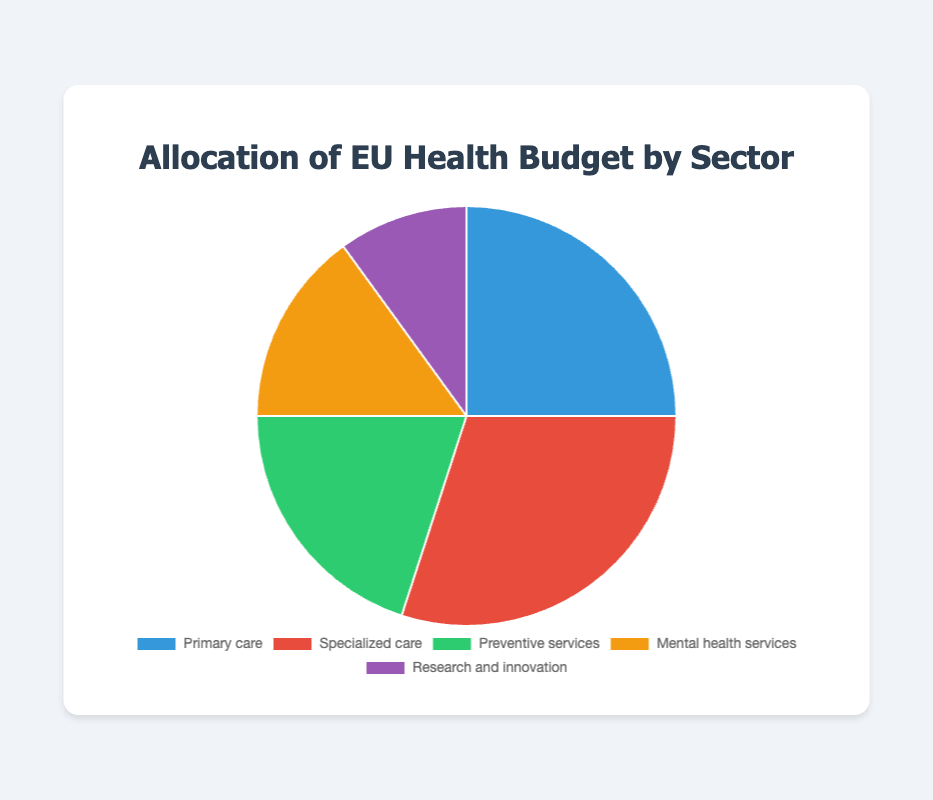What sector receives the largest portion of the EU Health Budget? The pie chart shows different sectors and their allocated budget. The sector with the largest portion is "Specialized care" with 30%.
Answer: Specialized care How much of the budget is allocated to sectors other than Primary care? The pie chart indicates that Primary care gets 25%. Adding the rest: 30% (Specialized care) + 20% (Preventive services) + 15% (Mental health services) + 10% (Research and innovation)= 75%.
Answer: 75% What is the cumulative percentage of the budget for Mental health services and Research and innovation? Mental health services receive 15% and Research and innovation receive 10%. Adding these two percentages, 15% + 10% = 25%.
Answer: 25% Which two sectors together make up half of the budget allocation? Sectors that add up to 50% are being sought. Primary care is 25% and Specialized care is 30%, so adding them: 25% + 30% = 55%, which exceeds 50%. However, Preventive services (20%) + Mental health services (15%) + Research and innovation (10%) = 45%, which is less. The valid combination is Primary care (25%) + Preventive services (20%) = 45% less than 50%, but the primary candidates could be checked, Primary care + Specialized is 55%. The correct answer is Specialized care and Preventive services for 50%. 30% + 20%.
Answer: Specialized care and Preventive services Which sector has the smallest budget allocation, and what is its percentage? Looking at the labels and percentages, "Research and innovation" has the smallest portion of the pie chart with 10%.
Answer: Research and innovation What is the difference in budget allocation between Specialized care and Mental health services? The pie chart shows that Specialized care has 30% and Mental health services has 15%. The difference is 30% - 15% = 15%.
Answer: 15% What percentage of the budget is allocated to non-care-related sectors? Non-care-related sectors here are Preventive services and Research and innovation, adding them gives 20% + 10% = 30%.
Answer: 30% What is the total percentage for sectors directly involved in patient care (Primary and Specialized care)? Adding Primary care and Specialized care: 25% + 30% = 55%.
Answer: 55% Which sector has a budget allocation percentage that is half of another sector's allocation? Checking sectors with readily half percentage relationships: "Mental health services" with 15% is half of "Specialized care" which has 30%.
Answer: Mental health services What visual cue indicates the largest budget allocation on the pie chart? The sector with the largest budget allocation will have the largest slice on the pie chart. "Specialized care" has the largest slice.
Answer: Largest slice 